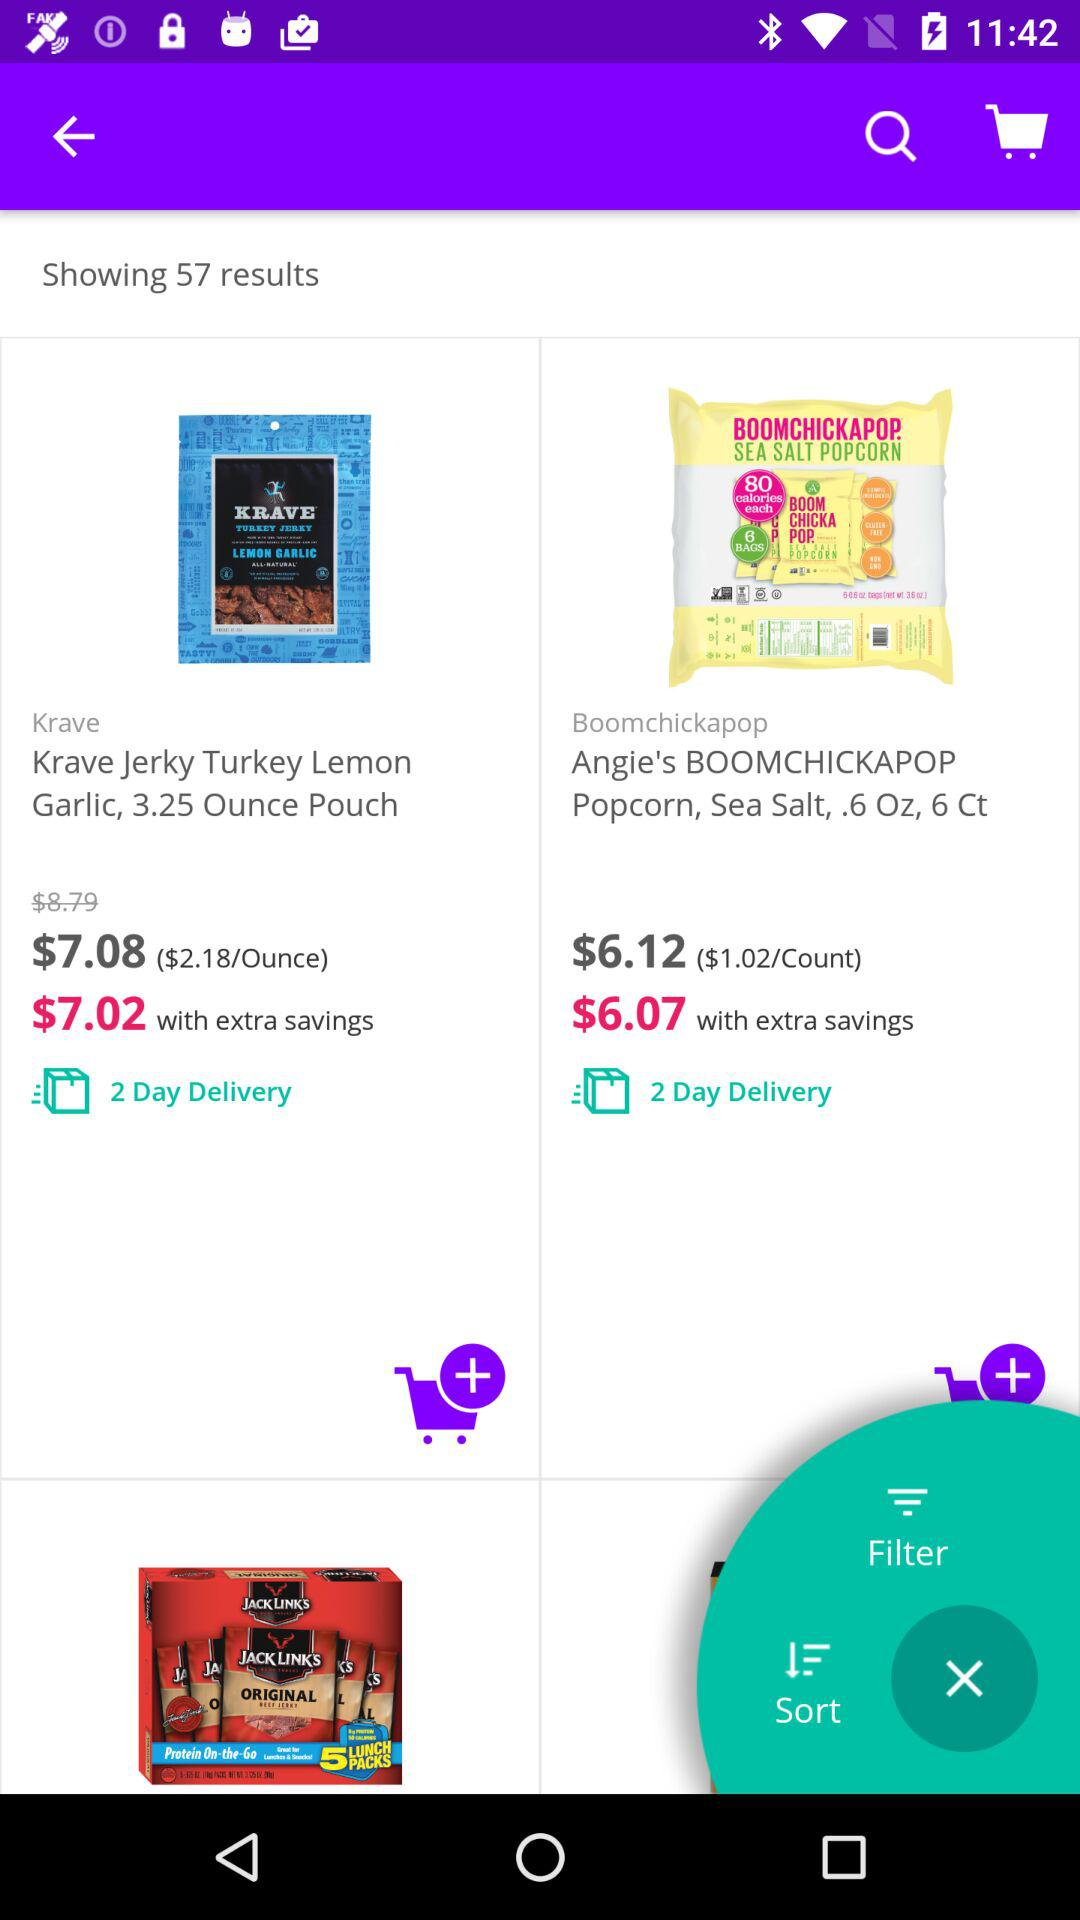What is the original price of "Krave Turkey Jerky" in a 3.25 ounce pouch? The original price is $8.79. 